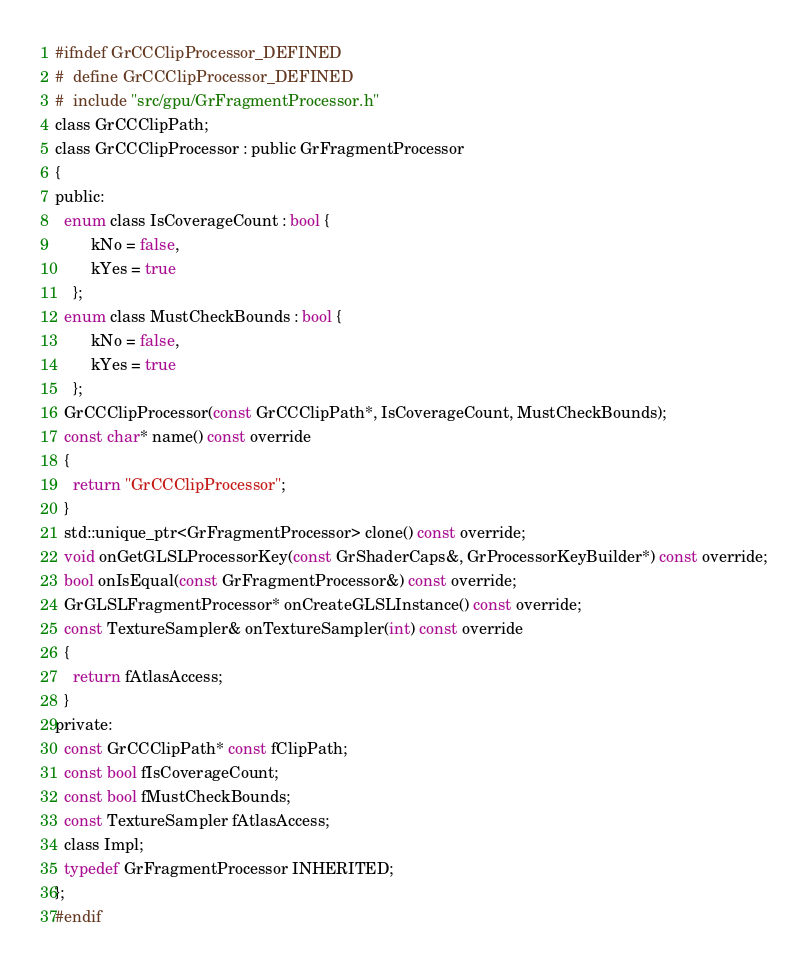Convert code to text. <code><loc_0><loc_0><loc_500><loc_500><_C_>#ifndef GrCCClipProcessor_DEFINED
#  define GrCCClipProcessor_DEFINED
#  include "src/gpu/GrFragmentProcessor.h"
class GrCCClipPath;
class GrCCClipProcessor : public GrFragmentProcessor
{
public:
  enum class IsCoverageCount : bool {
        kNo = false,
        kYes = true
    };
  enum class MustCheckBounds : bool {
        kNo = false,
        kYes = true
    };
  GrCCClipProcessor(const GrCCClipPath*, IsCoverageCount, MustCheckBounds);
  const char* name() const override
  {
    return "GrCCClipProcessor";
  }
  std::unique_ptr<GrFragmentProcessor> clone() const override;
  void onGetGLSLProcessorKey(const GrShaderCaps&, GrProcessorKeyBuilder*) const override;
  bool onIsEqual(const GrFragmentProcessor&) const override;
  GrGLSLFragmentProcessor* onCreateGLSLInstance() const override;
  const TextureSampler& onTextureSampler(int) const override
  {
    return fAtlasAccess;
  }
private:
  const GrCCClipPath* const fClipPath;
  const bool fIsCoverageCount;
  const bool fMustCheckBounds;
  const TextureSampler fAtlasAccess;
  class Impl;
  typedef GrFragmentProcessor INHERITED;
};
#endif
</code> 